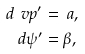Convert formula to latex. <formula><loc_0><loc_0><loc_500><loc_500>d \ v p ^ { \prime } & = \ a , \\ d \psi ^ { \prime } & = \beta ,</formula> 